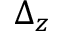Convert formula to latex. <formula><loc_0><loc_0><loc_500><loc_500>\Delta _ { z }</formula> 